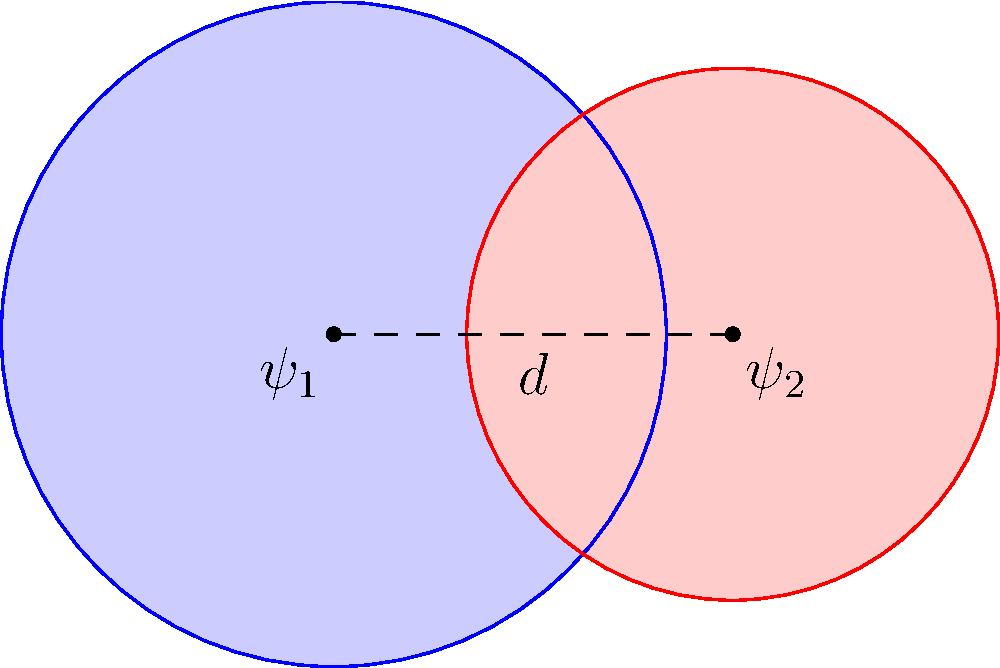Consider two circular wavefunctions $\psi_1$ and $\psi_2$ in a 2D plane, representing the probability distributions of two particles in a quantum system. $\psi_1$ has a radius of 1.5 units and is centered at the origin, while $\psi_2$ has a radius of 1.2 units and its center is 1.8 units away from the origin along the x-axis. Calculate the area of overlap between these two wavefunctions, which represents the probability of finding both particles in the same region. To solve this problem, we'll follow these steps:

1) First, we need to determine if the circles intersect. The distance between centers is 1.8, and the sum of radii is 1.5 + 1.2 = 2.7. Since 1.8 < 2.7, the circles do intersect.

2) We can use the formula for the area of intersection of two circles:

   $A = r_1^2 \arccos(\frac{d^2 + r_1^2 - r_2^2}{2dr_1}) + r_2^2 \arccos(\frac{d^2 + r_2^2 - r_1^2}{2dr_2}) - \frac{1}{2}\sqrt{(-d+r_1+r_2)(d+r_1-r_2)(d-r_1+r_2)(d+r_1+r_2)}$

   where $r_1$ and $r_2$ are the radii of the circles and $d$ is the distance between their centers.

3) Plugging in our values:
   $r_1 = 1.5$, $r_2 = 1.2$, $d = 1.8$

4) Calculate each term:
   
   Term 1: $1.5^2 \arccos(\frac{1.8^2 + 1.5^2 - 1.2^2}{2 * 1.8 * 1.5}) = 2.25 * 0.5880 = 1.3230$
   
   Term 2: $1.2^2 \arccos(\frac{1.8^2 + 1.2^2 - 1.5^2}{2 * 1.8 * 1.2}) = 1.44 * 1.0472 = 1.5080$
   
   Term 3: $-\frac{1}{2}\sqrt{(-1.8+1.5+1.2)(1.8+1.5-1.2)(1.8-1.5+1.2)(1.8+1.5+1.2)} = -0.8930$

5) Sum up all terms:
   $A = 1.3230 + 1.5080 - 0.8930 = 1.9380$ square units

This area represents the probability of finding both particles in the overlapping region of their wavefunctions.
Answer: 1.9380 square units 